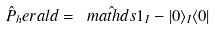<formula> <loc_0><loc_0><loc_500><loc_500>\hat { P } _ { h } e r a l d = \hat { \ m a t h d s { 1 } } _ { I } - | 0 \rangle _ { I } \langle 0 |</formula> 